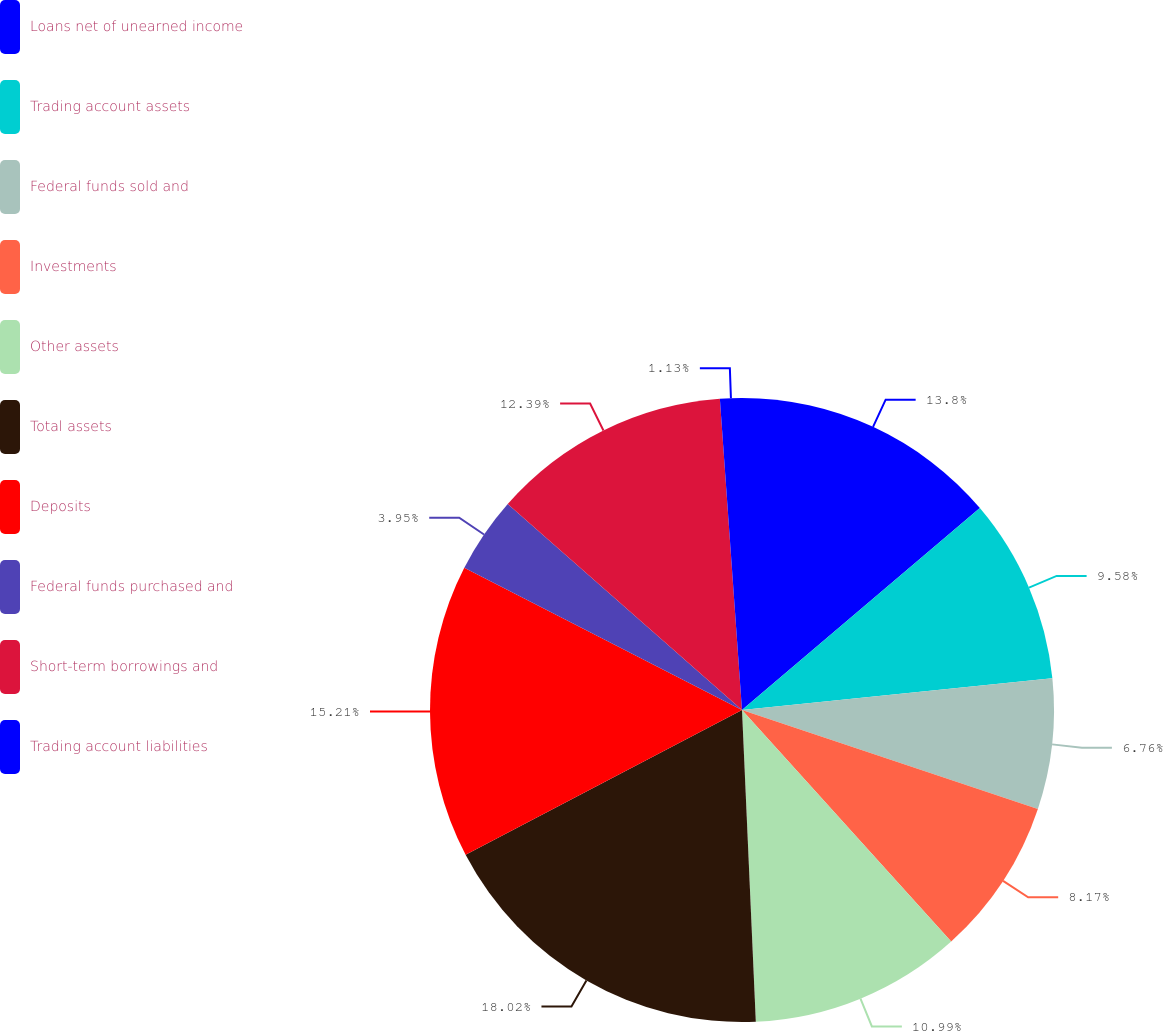<chart> <loc_0><loc_0><loc_500><loc_500><pie_chart><fcel>Loans net of unearned income<fcel>Trading account assets<fcel>Federal funds sold and<fcel>Investments<fcel>Other assets<fcel>Total assets<fcel>Deposits<fcel>Federal funds purchased and<fcel>Short-term borrowings and<fcel>Trading account liabilities<nl><fcel>13.8%<fcel>9.58%<fcel>6.76%<fcel>8.17%<fcel>10.99%<fcel>18.03%<fcel>15.21%<fcel>3.95%<fcel>12.39%<fcel>1.13%<nl></chart> 